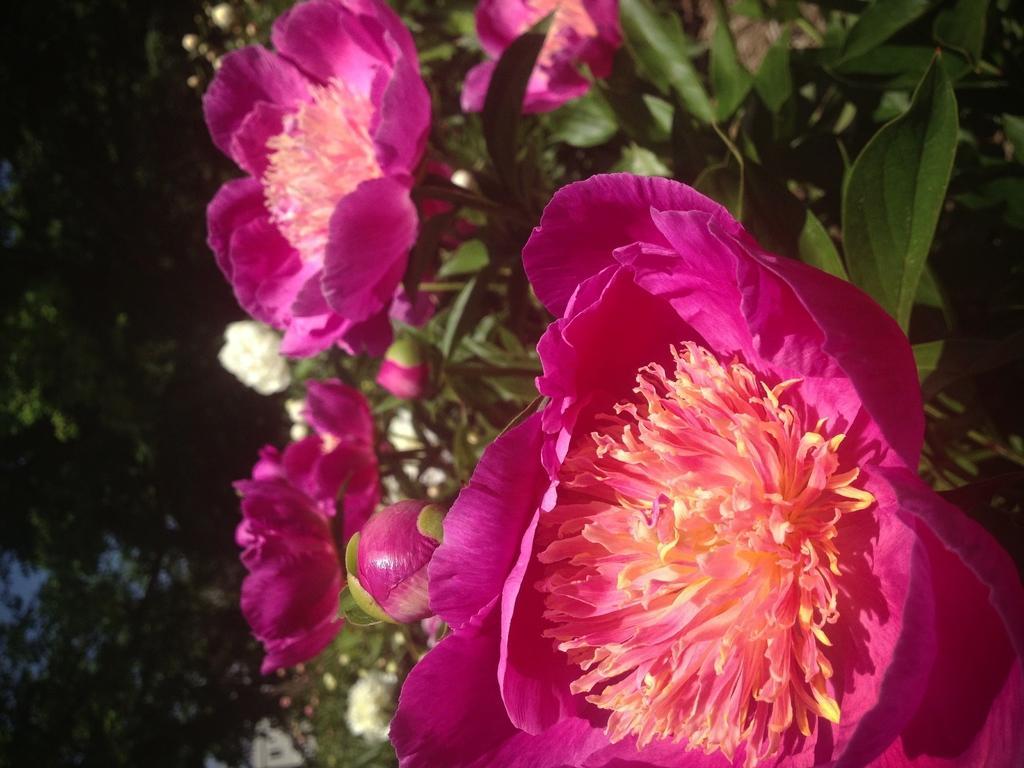In one or two sentences, can you explain what this image depicts? In the picture I can see flower plants. These flowers are pink in color. The background of the image is dark. 